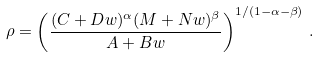Convert formula to latex. <formula><loc_0><loc_0><loc_500><loc_500>\rho = \left ( \frac { ( C + D w ) ^ { \alpha } ( M + N w ) ^ { \beta } } { A + B w } \right ) ^ { 1 / ( 1 - \alpha - \beta ) } \, .</formula> 